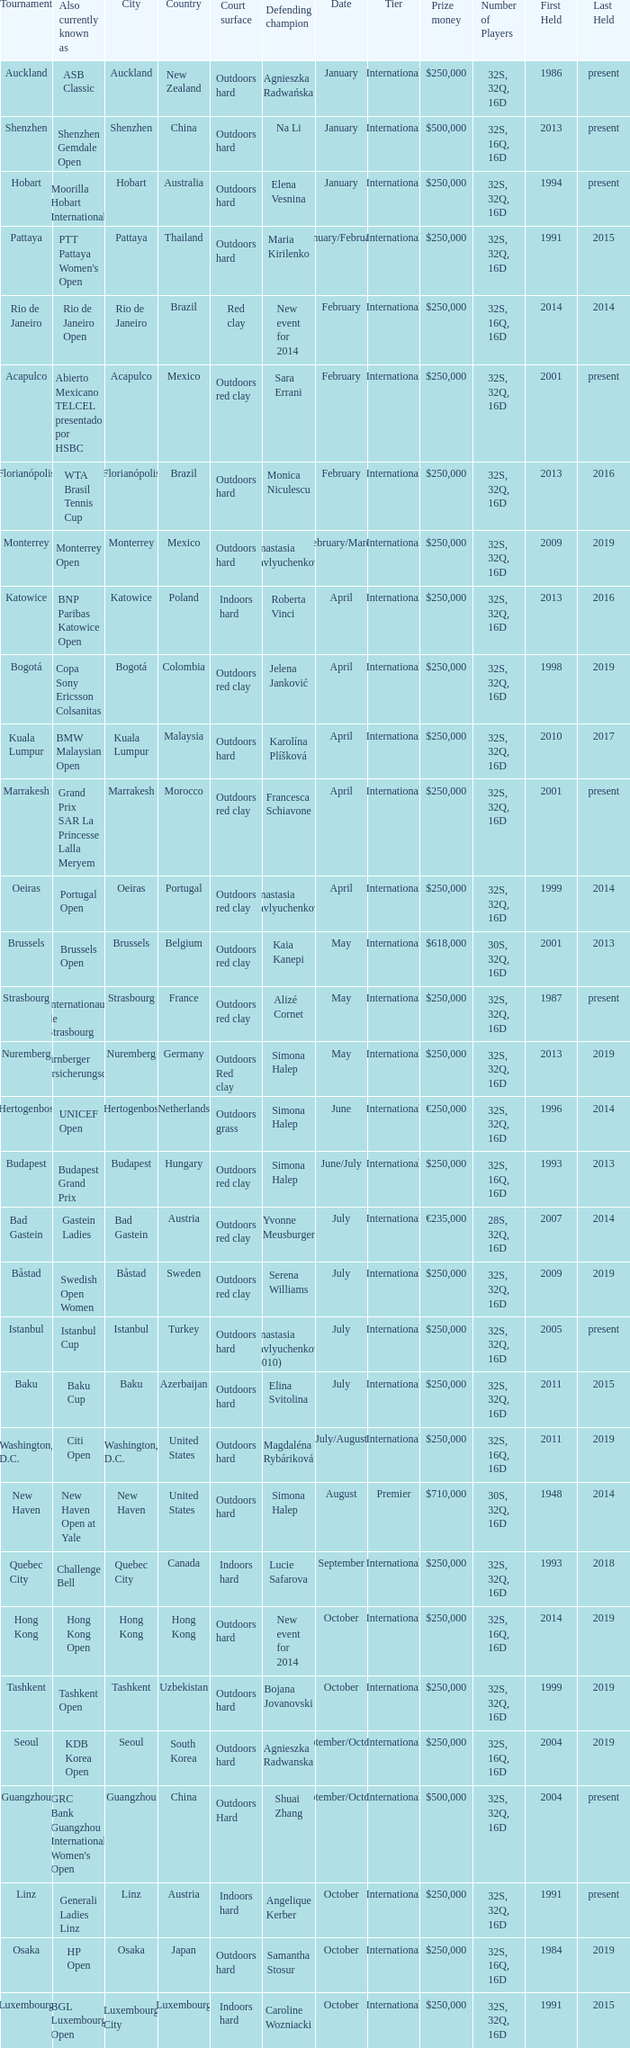What tournament is in katowice? Katowice. 